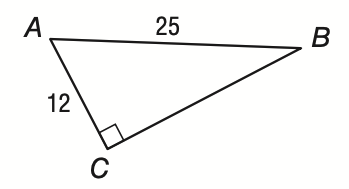Answer the mathemtical geometry problem and directly provide the correct option letter.
Question: If A C = 12 and A B = 25, what is the measure of \angle B to the nearest tenth?
Choices: A: 25.6 B: 28.7 C: 61.3 D: 64.4 B 